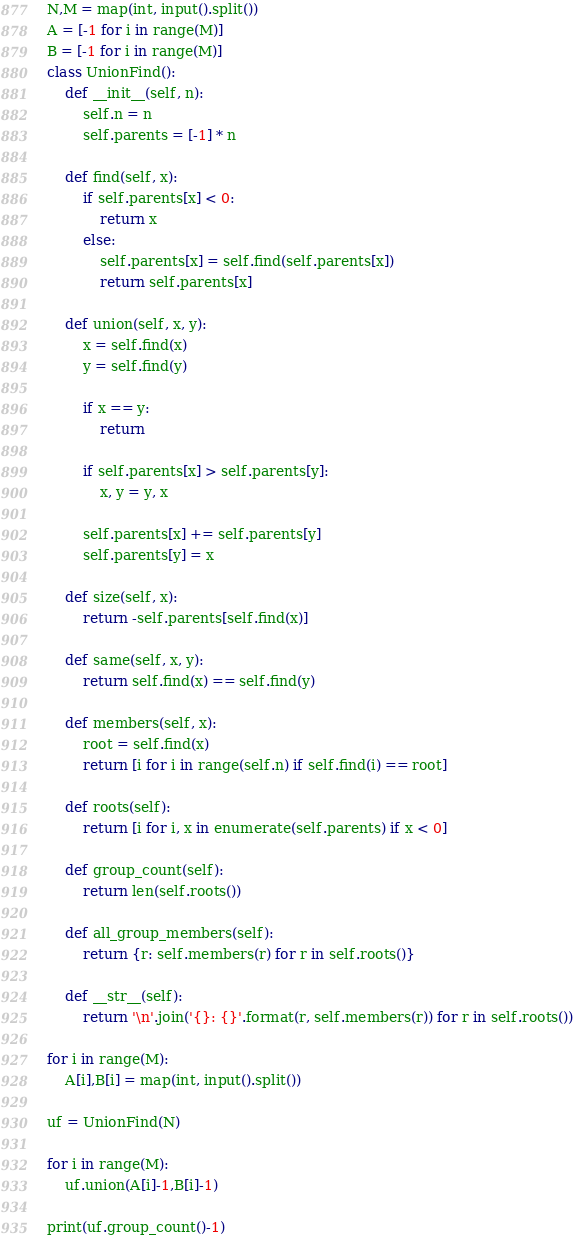<code> <loc_0><loc_0><loc_500><loc_500><_Python_>
N,M = map(int, input().split())
A = [-1 for i in range(M)]
B = [-1 for i in range(M)]
class UnionFind():
    def __init__(self, n):
        self.n = n
        self.parents = [-1] * n

    def find(self, x):
        if self.parents[x] < 0:
            return x
        else:
            self.parents[x] = self.find(self.parents[x])
            return self.parents[x]

    def union(self, x, y):
        x = self.find(x)
        y = self.find(y)

        if x == y:
            return

        if self.parents[x] > self.parents[y]:
            x, y = y, x

        self.parents[x] += self.parents[y]
        self.parents[y] = x

    def size(self, x):
        return -self.parents[self.find(x)]

    def same(self, x, y):
        return self.find(x) == self.find(y)

    def members(self, x):
        root = self.find(x)
        return [i for i in range(self.n) if self.find(i) == root]

    def roots(self):
        return [i for i, x in enumerate(self.parents) if x < 0]

    def group_count(self):
        return len(self.roots())

    def all_group_members(self):
        return {r: self.members(r) for r in self.roots()}

    def __str__(self):
        return '\n'.join('{}: {}'.format(r, self.members(r)) for r in self.roots())

for i in range(M):
    A[i],B[i] = map(int, input().split())

uf = UnionFind(N)

for i in range(M):
    uf.union(A[i]-1,B[i]-1)

print(uf.group_count()-1)</code> 